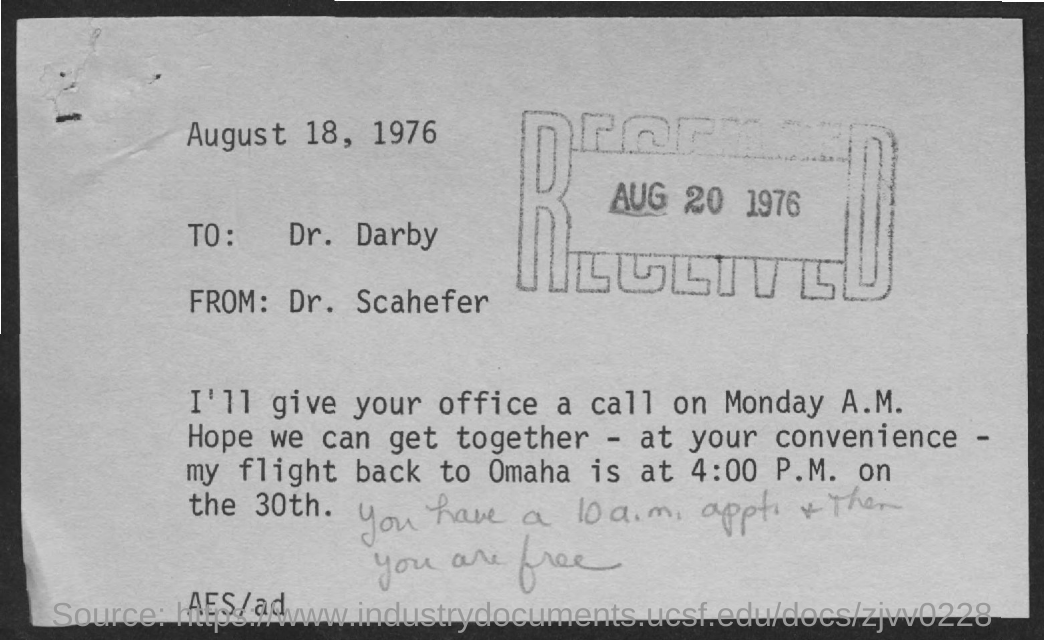Whom is the letter addresed to?
Keep it short and to the point. Dr. Darby. What is the time of flight back to Omaha?
Provide a succinct answer. 4:00 P.M. When is the office call scheduled?
Make the answer very short. Monday. What is the date on the stamp?
Keep it short and to the point. Aug 20 1976. What is the date at which the letter is written?
Make the answer very short. August 18, 1976. What is the from address of the letter?
Your answer should be very brief. Dr. scahefer. 